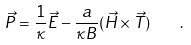<formula> <loc_0><loc_0><loc_500><loc_500>\vec { P } = \frac { 1 } { \kappa } \vec { E } - \frac { a } { \kappa B } ( \vec { H } \times \vec { T } ) \quad .</formula> 